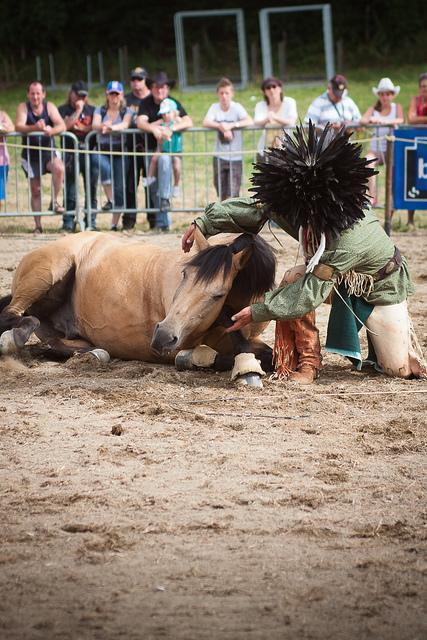Most horses that are used for racing are ridden by professional riders called as?
Make your selection from the four choices given to correctly answer the question.
Options: Equestrian, jockeys, riders, trainers. Jockeys. 